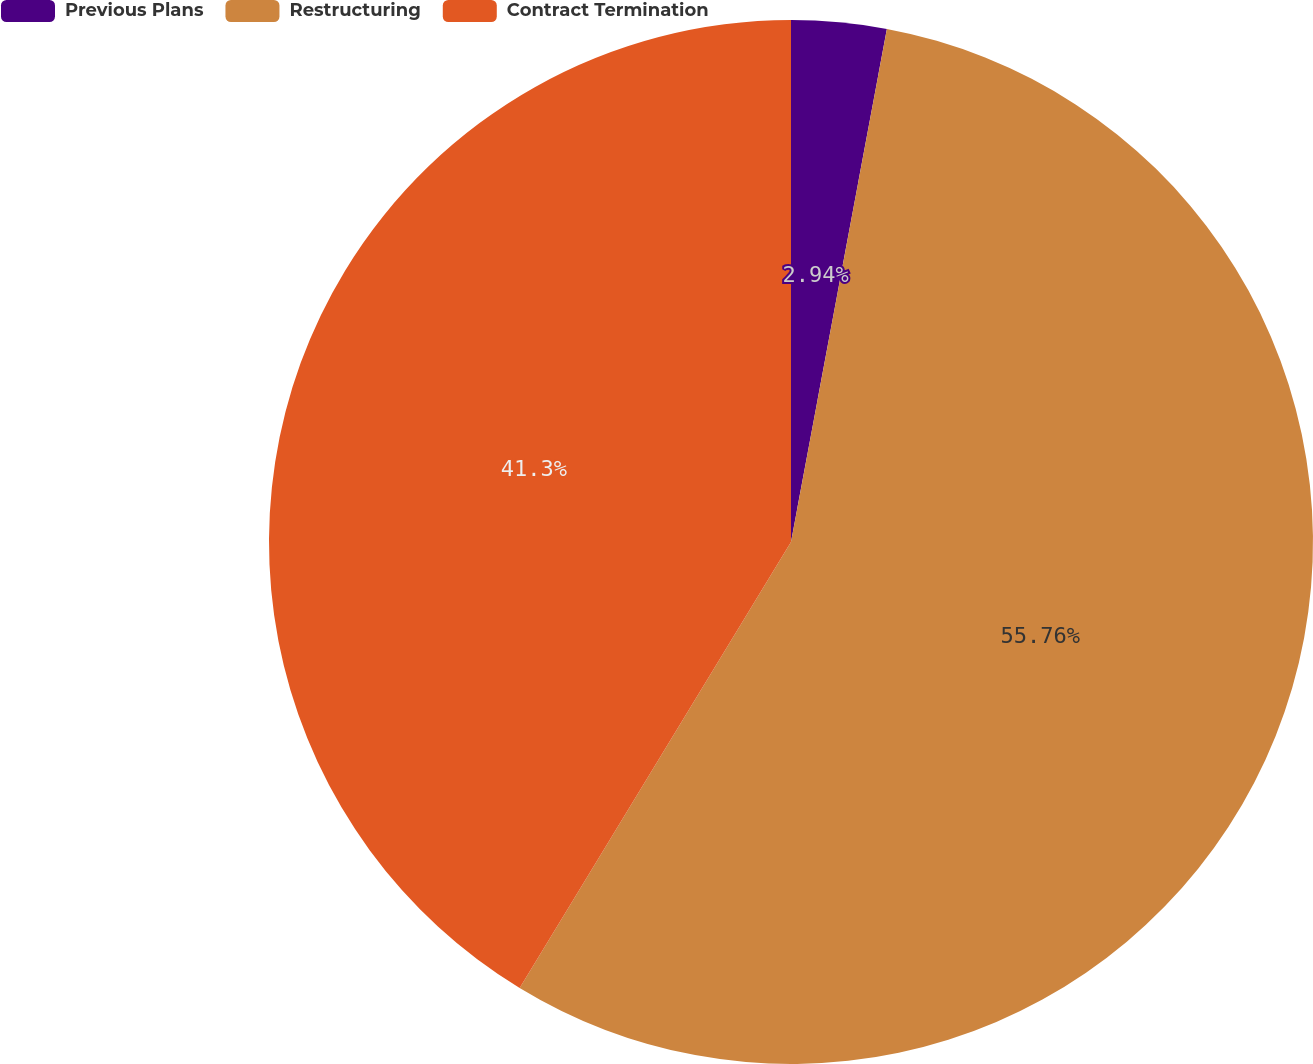<chart> <loc_0><loc_0><loc_500><loc_500><pie_chart><fcel>Previous Plans<fcel>Restructuring<fcel>Contract Termination<nl><fcel>2.94%<fcel>55.76%<fcel>41.3%<nl></chart> 